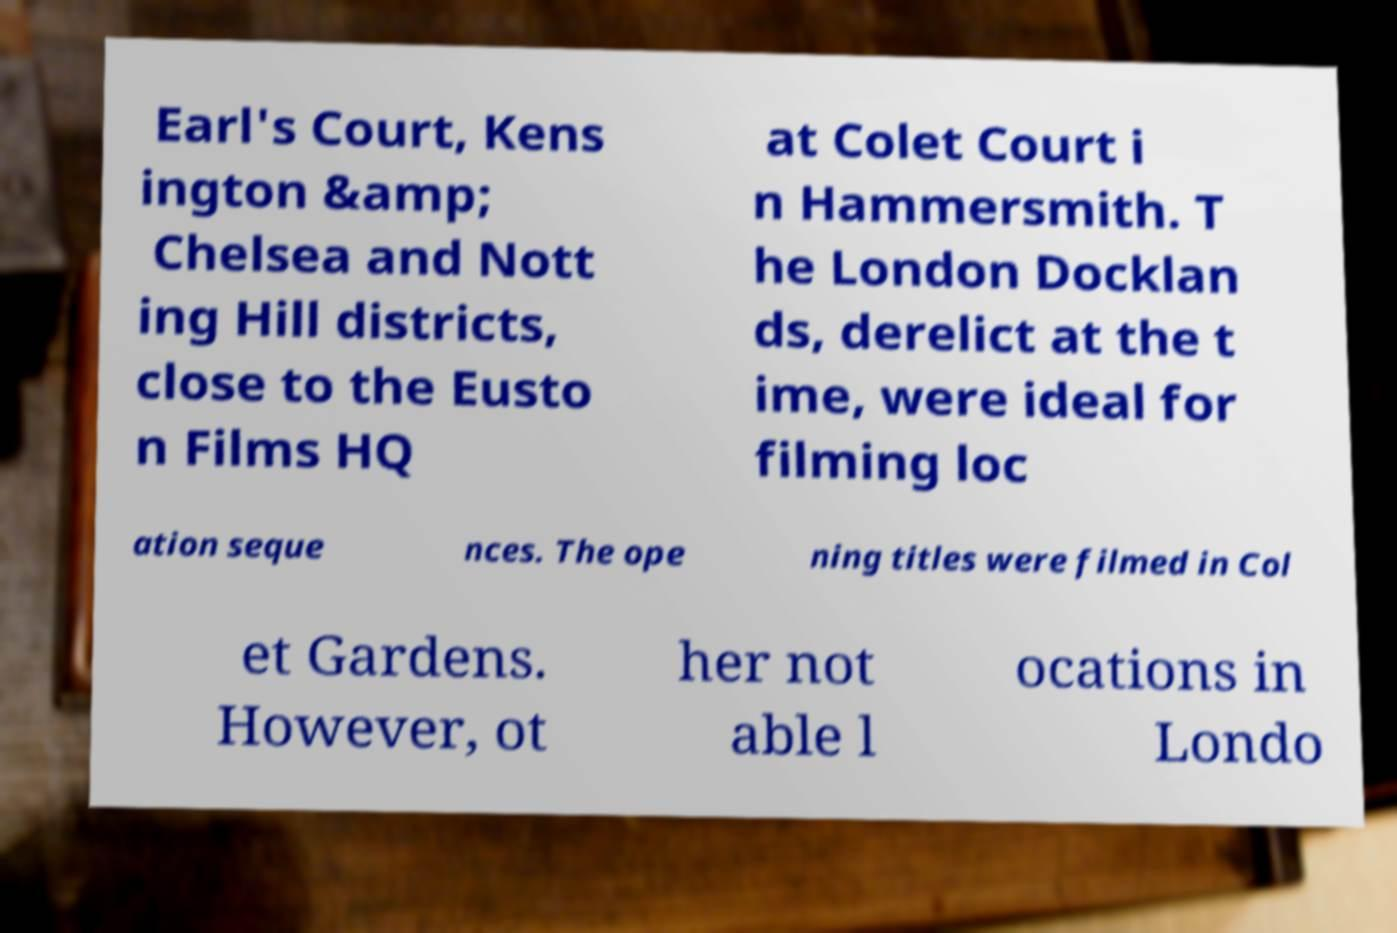Can you accurately transcribe the text from the provided image for me? Earl's Court, Kens ington &amp; Chelsea and Nott ing Hill districts, close to the Eusto n Films HQ at Colet Court i n Hammersmith. T he London Docklan ds, derelict at the t ime, were ideal for filming loc ation seque nces. The ope ning titles were filmed in Col et Gardens. However, ot her not able l ocations in Londo 